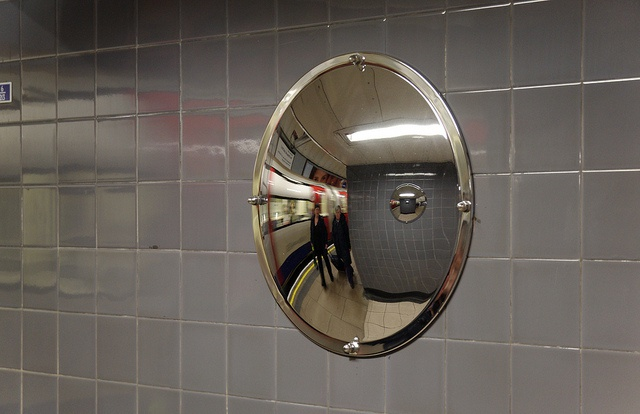Describe the objects in this image and their specific colors. I can see people in gray, black, and maroon tones, people in gray, black, maroon, and olive tones, and suitcase in black and gray tones in this image. 